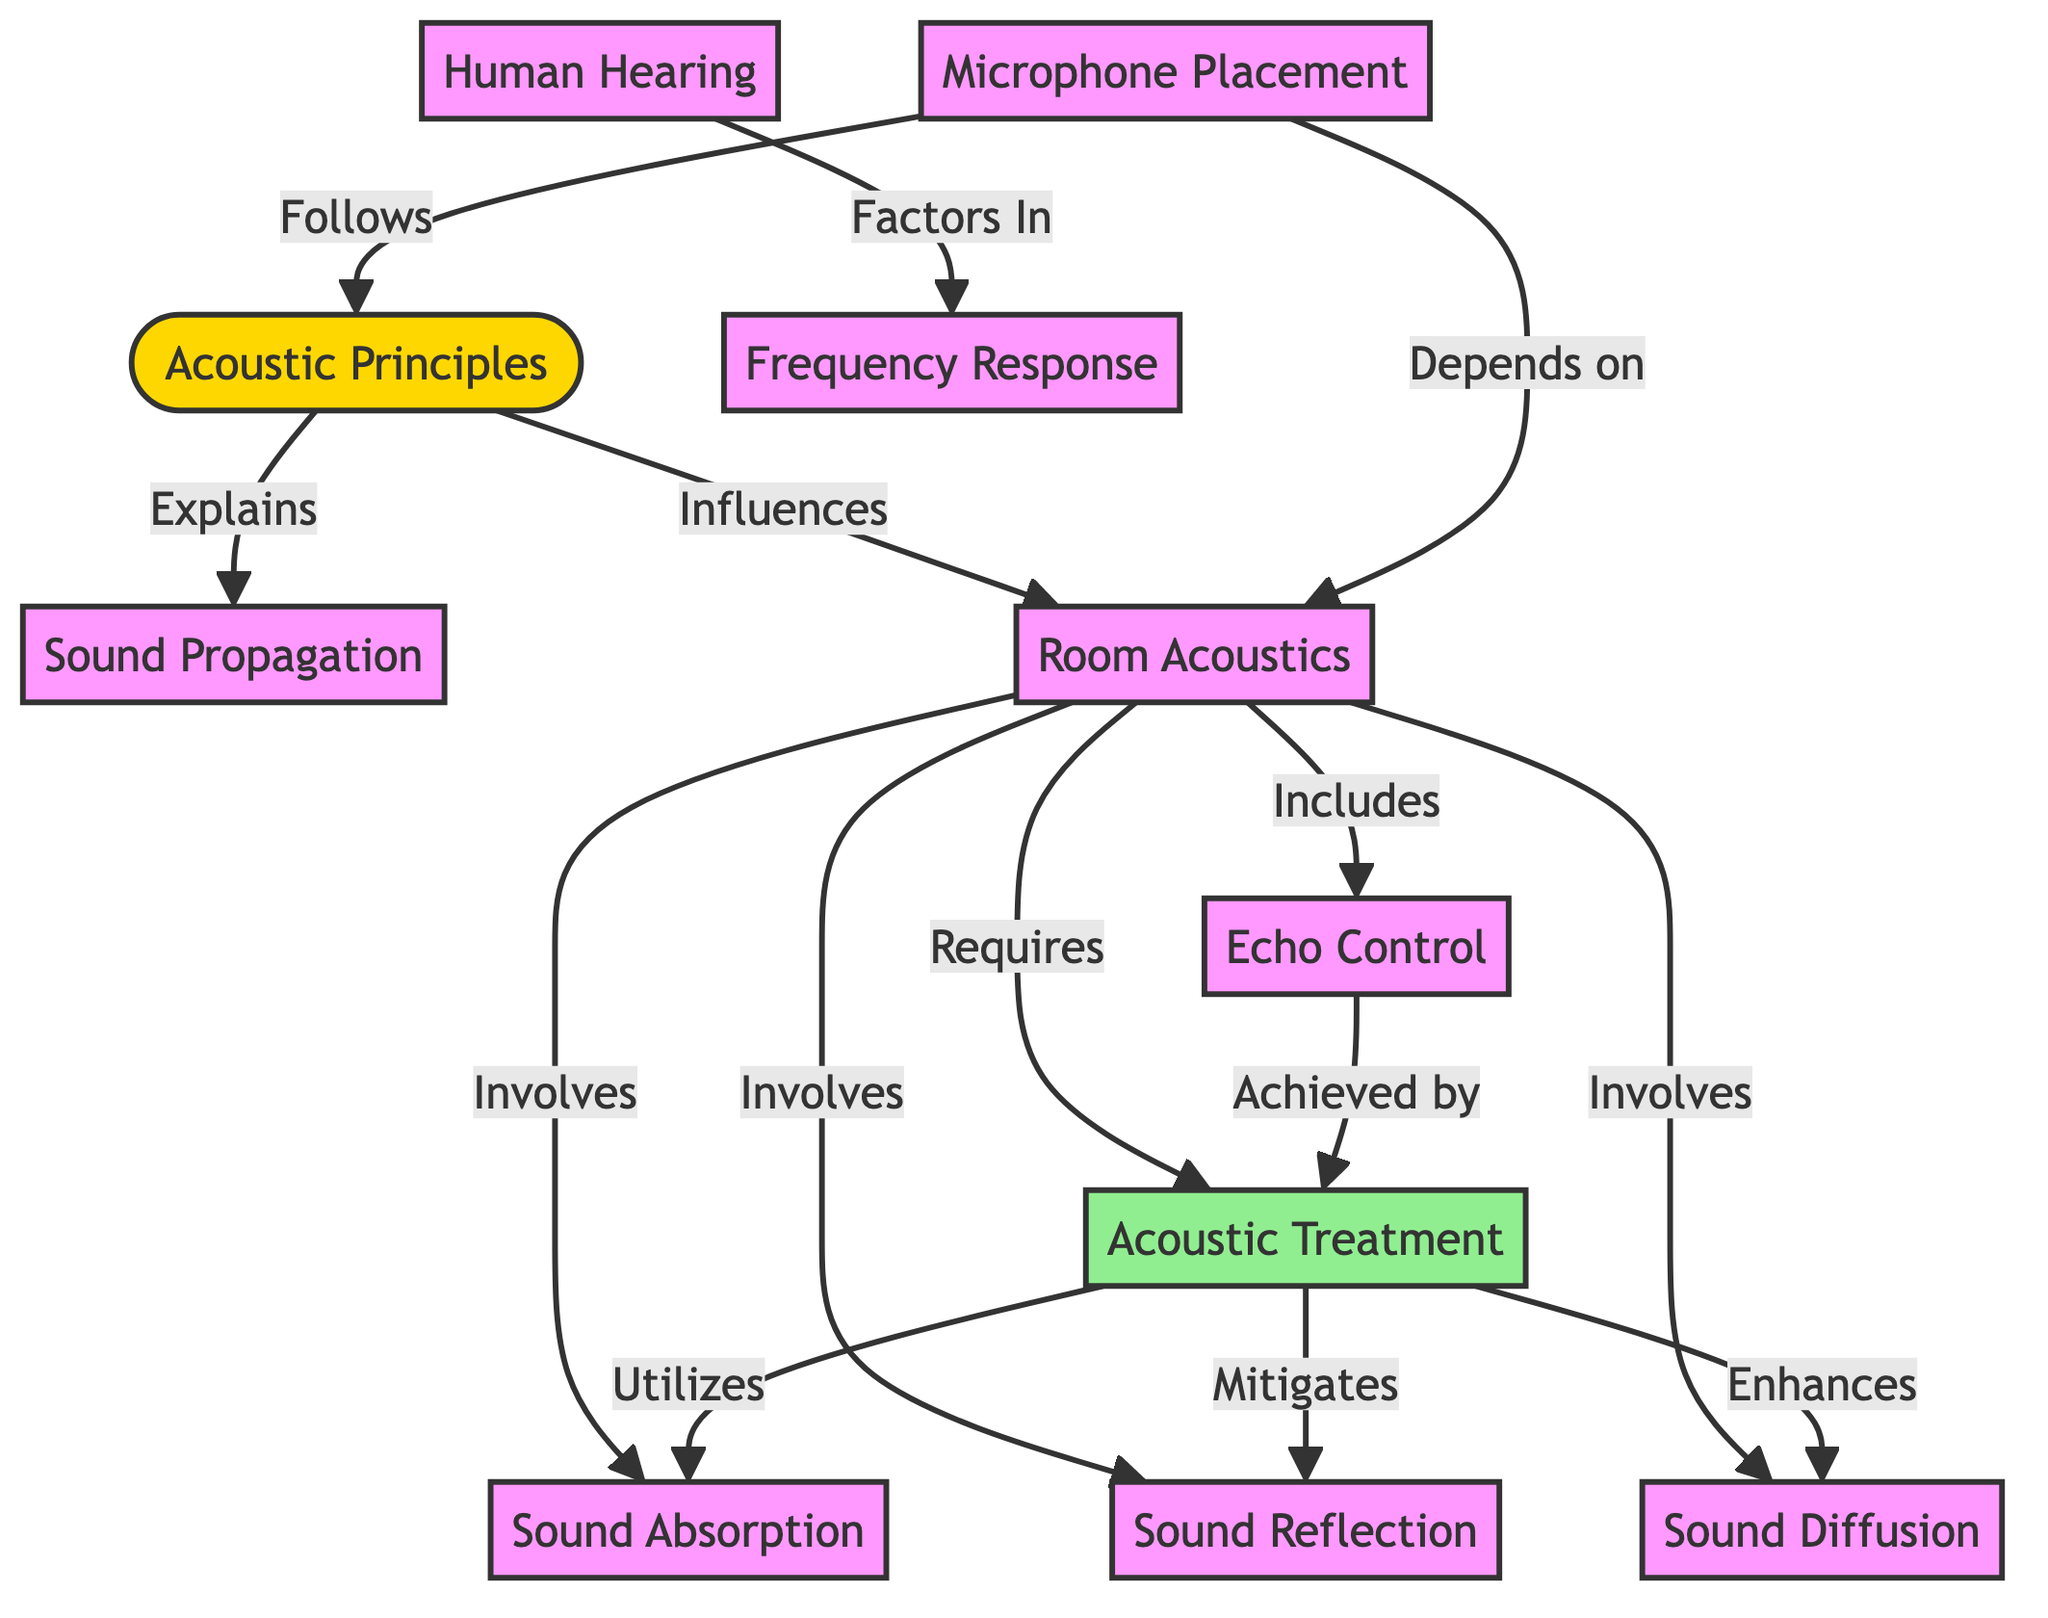What are the main components of Acoustic Principles? The diagram identifies that Acoustic Principles consists of Sound Propagation, Room Acoustics, and Human Hearing. These are the key components directly connected to Acoustic Principles.
Answer: Sound Propagation, Room Acoustics, Human Hearing How many types of acoustic treatments are listed? The diagram outlines three specific treatments under Acoustic Treatment: Sound Absorption, Sound Reflection, and Sound Diffusion. By counting these, we see there are three types.
Answer: 3 What does Room Acoustics require? According to the diagram, Room Acoustics directly requires Acoustic Treatment, as indicated by the arrow from Room Acoustics to Acoustic Treatment.
Answer: Acoustic Treatment What factors into the Frequency Response? Human Hearing factors into Frequency Response as shown in the diagram, highlighting the relationship between these two components.
Answer: Human Hearing How does Echo Control relate to Acoustic Treatment? The diagram shows that Echo Control is achieved by Acoustic Treatment, indicating a direct causal relationship that demonstrates how treatment influences echo in a space.
Answer: Acoustic Treatment Which node does Microphone Placement depend on? The diagram clearly indicates that Microphone Placement depends on Room Acoustics, as it is linked with a directional arrow.
Answer: Room Acoustics What are the possible influences on Room Acoustics? The influences on Room Acoustics as per the diagram are Acoustic Treatment, Sound Absorption, Sound Reflection, Sound Diffusion, and Echo Control. There are several elements that involve Room Acoustics.
Answer: Acoustic Treatment, Sound Absorption, Sound Reflection, Sound Diffusion, Echo Control Which treatment enhances Sound Diffusion? The diagram specifies that Acoustic Treatment enhances Sound Diffusion, highlighting the improving relationship between these two elements.
Answer: Acoustic Treatment What is the relationship between Acoustic Principles and Microphone Placement? The relationship is that Microphone Placement follows Acoustic Principles, as per the direct connection shown in the diagram, indicating a sequential dependency.
Answer: Follows 